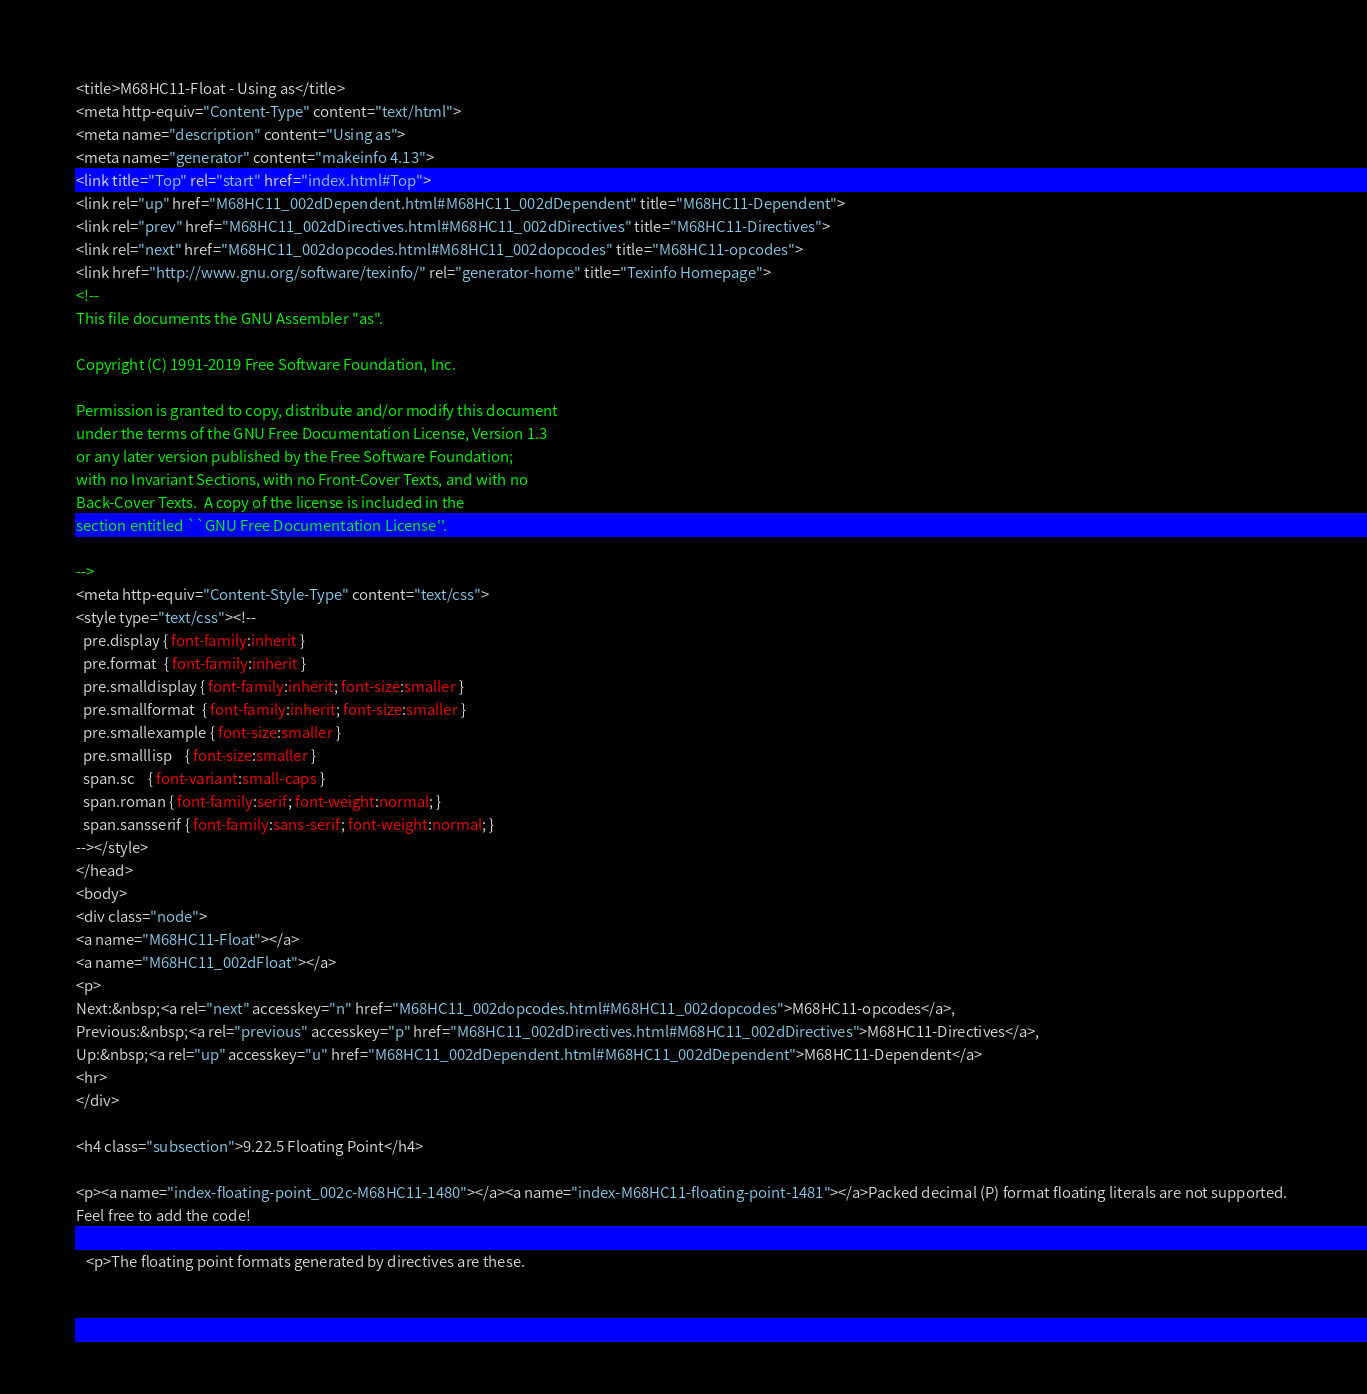<code> <loc_0><loc_0><loc_500><loc_500><_HTML_><title>M68HC11-Float - Using as</title>
<meta http-equiv="Content-Type" content="text/html">
<meta name="description" content="Using as">
<meta name="generator" content="makeinfo 4.13">
<link title="Top" rel="start" href="index.html#Top">
<link rel="up" href="M68HC11_002dDependent.html#M68HC11_002dDependent" title="M68HC11-Dependent">
<link rel="prev" href="M68HC11_002dDirectives.html#M68HC11_002dDirectives" title="M68HC11-Directives">
<link rel="next" href="M68HC11_002dopcodes.html#M68HC11_002dopcodes" title="M68HC11-opcodes">
<link href="http://www.gnu.org/software/texinfo/" rel="generator-home" title="Texinfo Homepage">
<!--
This file documents the GNU Assembler "as".

Copyright (C) 1991-2019 Free Software Foundation, Inc.

Permission is granted to copy, distribute and/or modify this document
under the terms of the GNU Free Documentation License, Version 1.3
or any later version published by the Free Software Foundation;
with no Invariant Sections, with no Front-Cover Texts, and with no
Back-Cover Texts.  A copy of the license is included in the
section entitled ``GNU Free Documentation License''.

-->
<meta http-equiv="Content-Style-Type" content="text/css">
<style type="text/css"><!--
  pre.display { font-family:inherit }
  pre.format  { font-family:inherit }
  pre.smalldisplay { font-family:inherit; font-size:smaller }
  pre.smallformat  { font-family:inherit; font-size:smaller }
  pre.smallexample { font-size:smaller }
  pre.smalllisp    { font-size:smaller }
  span.sc    { font-variant:small-caps }
  span.roman { font-family:serif; font-weight:normal; } 
  span.sansserif { font-family:sans-serif; font-weight:normal; } 
--></style>
</head>
<body>
<div class="node">
<a name="M68HC11-Float"></a>
<a name="M68HC11_002dFloat"></a>
<p>
Next:&nbsp;<a rel="next" accesskey="n" href="M68HC11_002dopcodes.html#M68HC11_002dopcodes">M68HC11-opcodes</a>,
Previous:&nbsp;<a rel="previous" accesskey="p" href="M68HC11_002dDirectives.html#M68HC11_002dDirectives">M68HC11-Directives</a>,
Up:&nbsp;<a rel="up" accesskey="u" href="M68HC11_002dDependent.html#M68HC11_002dDependent">M68HC11-Dependent</a>
<hr>
</div>

<h4 class="subsection">9.22.5 Floating Point</h4>

<p><a name="index-floating-point_002c-M68HC11-1480"></a><a name="index-M68HC11-floating-point-1481"></a>Packed decimal (P) format floating literals are not supported. 
Feel free to add the code!

   <p>The floating point formats generated by directives are these.

     </code> 